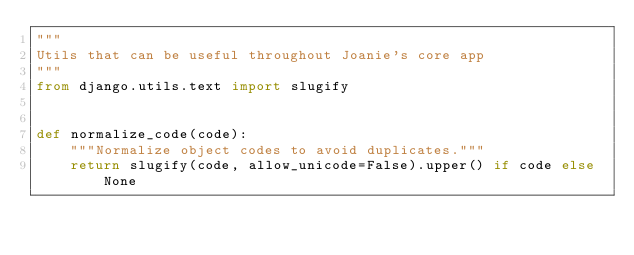<code> <loc_0><loc_0><loc_500><loc_500><_Python_>"""
Utils that can be useful throughout Joanie's core app
"""
from django.utils.text import slugify


def normalize_code(code):
    """Normalize object codes to avoid duplicates."""
    return slugify(code, allow_unicode=False).upper() if code else None
</code> 